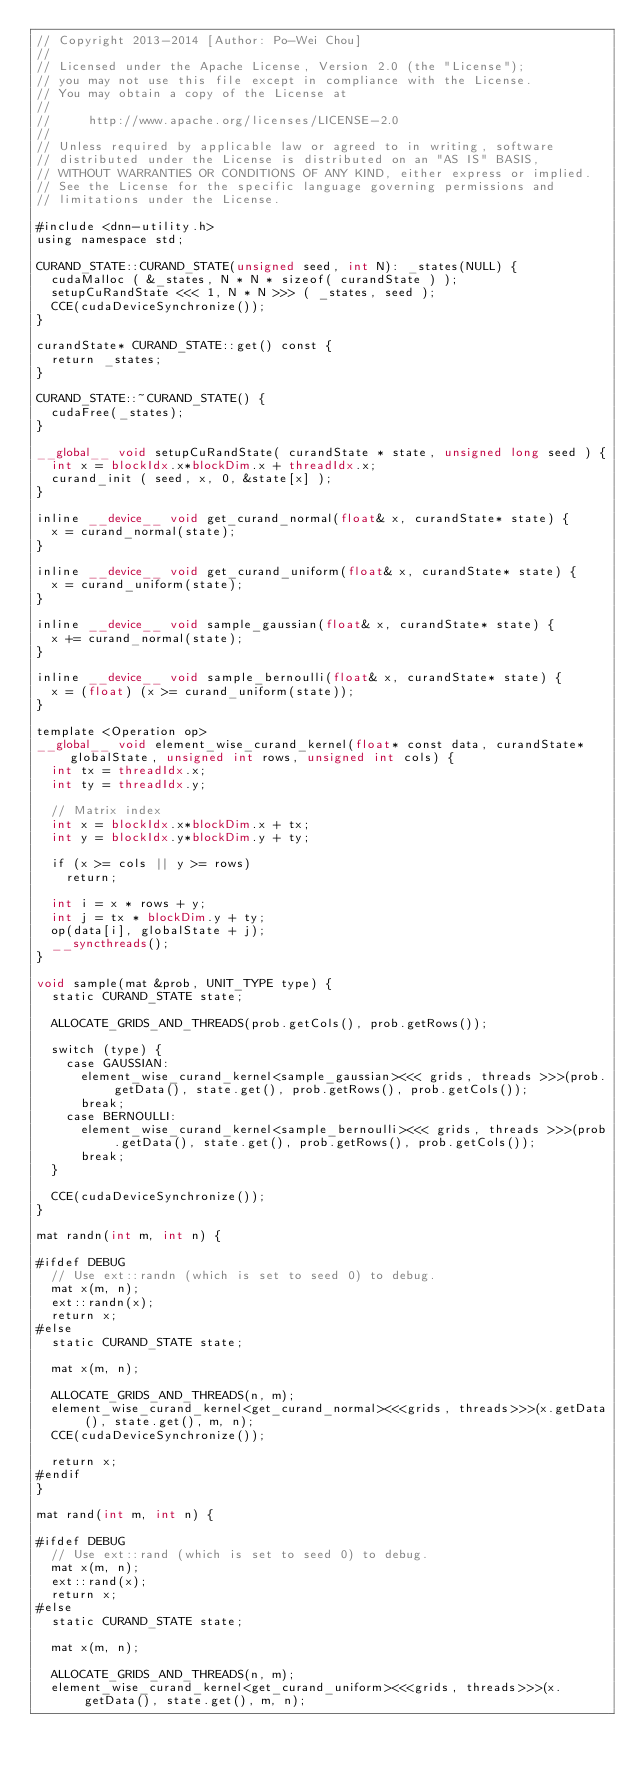Convert code to text. <code><loc_0><loc_0><loc_500><loc_500><_Cuda_>// Copyright 2013-2014 [Author: Po-Wei Chou]
// 
// Licensed under the Apache License, Version 2.0 (the "License");
// you may not use this file except in compliance with the License.
// You may obtain a copy of the License at
// 
//     http://www.apache.org/licenses/LICENSE-2.0
// 
// Unless required by applicable law or agreed to in writing, software
// distributed under the License is distributed on an "AS IS" BASIS,
// WITHOUT WARRANTIES OR CONDITIONS OF ANY KIND, either express or implied.
// See the License for the specific language governing permissions and
// limitations under the License.

#include <dnn-utility.h>
using namespace std;

CURAND_STATE::CURAND_STATE(unsigned seed, int N): _states(NULL) {
  cudaMalloc ( &_states, N * N * sizeof( curandState ) );
  setupCuRandState <<< 1, N * N >>> ( _states, seed );
  CCE(cudaDeviceSynchronize());
}

curandState* CURAND_STATE::get() const {
  return _states;
}

CURAND_STATE::~CURAND_STATE() {
  cudaFree(_states);
}

__global__ void setupCuRandState( curandState * state, unsigned long seed ) {
  int x = blockIdx.x*blockDim.x + threadIdx.x;
  curand_init ( seed, x, 0, &state[x] );
}

inline __device__ void get_curand_normal(float& x, curandState* state) {
  x = curand_normal(state);
}

inline __device__ void get_curand_uniform(float& x, curandState* state) {
  x = curand_uniform(state);
}

inline __device__ void sample_gaussian(float& x, curandState* state) {
  x += curand_normal(state);
}

inline __device__ void sample_bernoulli(float& x, curandState* state) {
  x = (float) (x >= curand_uniform(state));
}

template <Operation op>
__global__ void element_wise_curand_kernel(float* const data, curandState* globalState, unsigned int rows, unsigned int cols) {
  int tx = threadIdx.x;
  int ty = threadIdx.y;

  // Matrix index
  int x = blockIdx.x*blockDim.x + tx;
  int y = blockIdx.y*blockDim.y + ty;

  if (x >= cols || y >= rows)
    return;

  int i = x * rows + y;
  int j = tx * blockDim.y + ty;
  op(data[i], globalState + j);
  __syncthreads();
}

void sample(mat &prob, UNIT_TYPE type) {
  static CURAND_STATE state;

  ALLOCATE_GRIDS_AND_THREADS(prob.getCols(), prob.getRows());

  switch (type) {
    case GAUSSIAN:
      element_wise_curand_kernel<sample_gaussian><<< grids, threads >>>(prob.getData(), state.get(), prob.getRows(), prob.getCols());
      break;
    case BERNOULLI:
      element_wise_curand_kernel<sample_bernoulli><<< grids, threads >>>(prob.getData(), state.get(), prob.getRows(), prob.getCols());
      break;
  }

  CCE(cudaDeviceSynchronize());
}

mat randn(int m, int n) {

#ifdef DEBUG
  // Use ext::randn (which is set to seed 0) to debug.
  mat x(m, n);
  ext::randn(x);
  return x;
#else
  static CURAND_STATE state;

  mat x(m, n);

  ALLOCATE_GRIDS_AND_THREADS(n, m);
  element_wise_curand_kernel<get_curand_normal><<<grids, threads>>>(x.getData(), state.get(), m, n);
  CCE(cudaDeviceSynchronize());

  return x;
#endif
}

mat rand(int m, int n) {

#ifdef DEBUG
  // Use ext::rand (which is set to seed 0) to debug.
  mat x(m, n);
  ext::rand(x);
  return x;
#else
  static CURAND_STATE state;

  mat x(m, n);

  ALLOCATE_GRIDS_AND_THREADS(n, m);
  element_wise_curand_kernel<get_curand_uniform><<<grids, threads>>>(x.getData(), state.get(), m, n);</code> 